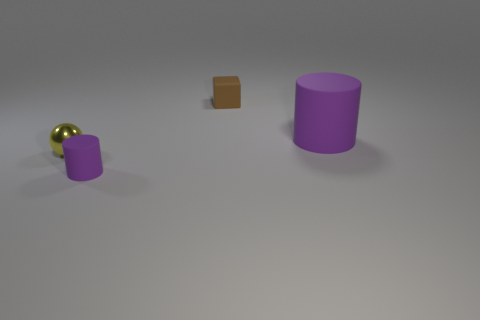There is a small matte cube to the right of the tiny metal object; is there a brown object that is left of it?
Ensure brevity in your answer.  No. Are there more purple matte things that are behind the tiny purple matte cylinder than spheres in front of the large matte object?
Keep it short and to the point. No. What number of big cylinders are the same color as the tiny rubber cylinder?
Provide a succinct answer. 1. There is a cylinder behind the yellow metallic sphere; is it the same color as the rubber object in front of the large purple cylinder?
Give a very brief answer. Yes. There is a small matte block; are there any objects behind it?
Your answer should be compact. No. What is the material of the tiny ball?
Give a very brief answer. Metal. The tiny rubber thing that is in front of the large purple object has what shape?
Your answer should be compact. Cylinder. There is another cylinder that is the same color as the small matte cylinder; what is its size?
Your response must be concise. Large. Are there any yellow balls of the same size as the brown block?
Make the answer very short. Yes. Are the tiny object that is on the right side of the small purple cylinder and the tiny purple cylinder made of the same material?
Your answer should be very brief. Yes. 